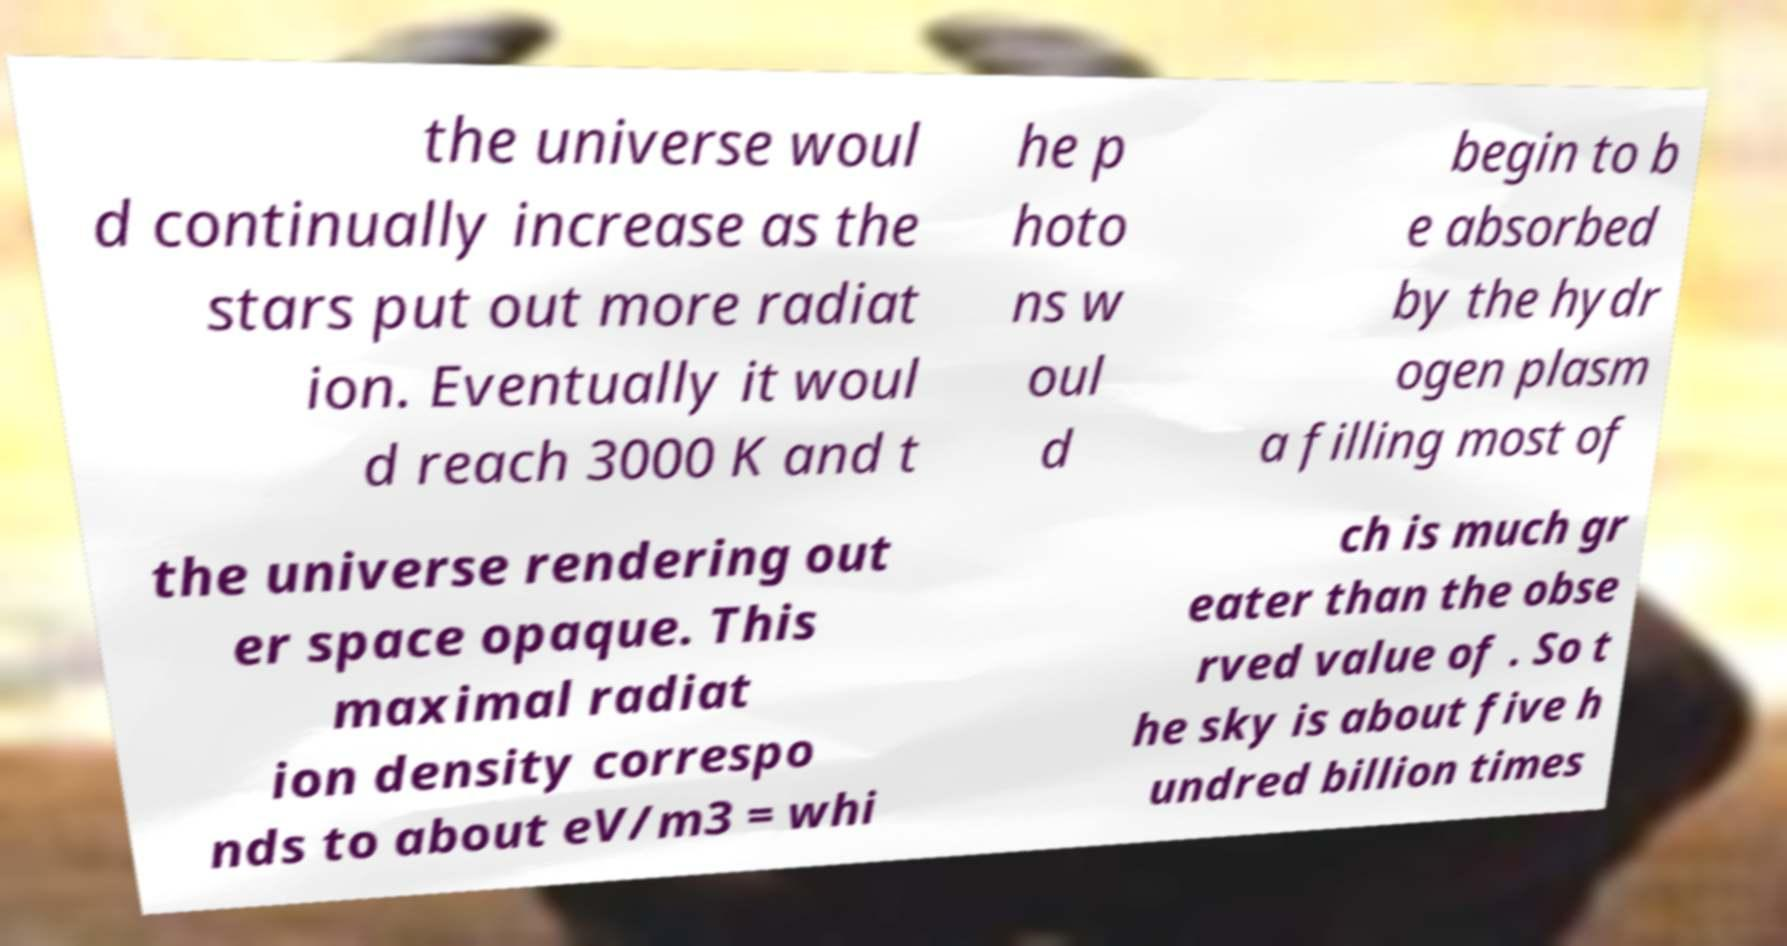Could you extract and type out the text from this image? the universe woul d continually increase as the stars put out more radiat ion. Eventually it woul d reach 3000 K and t he p hoto ns w oul d begin to b e absorbed by the hydr ogen plasm a filling most of the universe rendering out er space opaque. This maximal radiat ion density correspo nds to about eV/m3 = whi ch is much gr eater than the obse rved value of . So t he sky is about five h undred billion times 